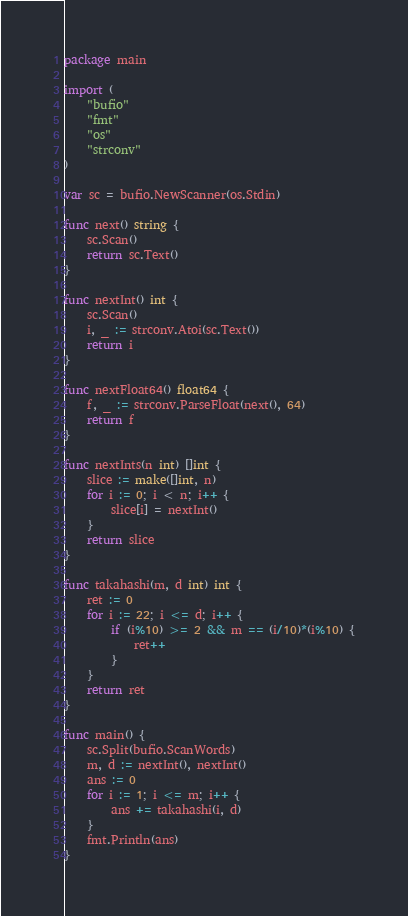<code> <loc_0><loc_0><loc_500><loc_500><_Go_>package main

import (
	"bufio"
	"fmt"
	"os"
	"strconv"
)

var sc = bufio.NewScanner(os.Stdin)

func next() string {
	sc.Scan()
	return sc.Text()
}

func nextInt() int {
	sc.Scan()
	i, _ := strconv.Atoi(sc.Text())
	return i
}

func nextFloat64() float64 {
	f, _ := strconv.ParseFloat(next(), 64)
	return f
}

func nextInts(n int) []int {
	slice := make([]int, n)
	for i := 0; i < n; i++ {
		slice[i] = nextInt()
	}
	return slice
}

func takahashi(m, d int) int {
	ret := 0
	for i := 22; i <= d; i++ {
		if (i%10) >= 2 && m == (i/10)*(i%10) {
			ret++
		}
	}
	return ret
}

func main() {
	sc.Split(bufio.ScanWords)
	m, d := nextInt(), nextInt()
	ans := 0
	for i := 1; i <= m; i++ {
		ans += takahashi(i, d)
	}
	fmt.Println(ans)
}
</code> 